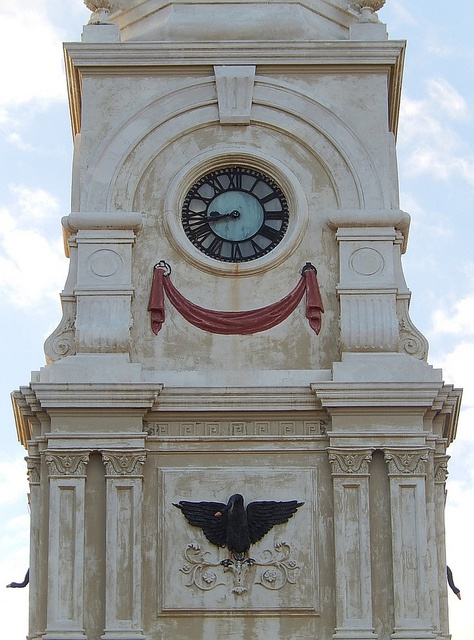Describe the objects in this image and their specific colors. I can see a clock in white, black, gray, and darkgray tones in this image. 